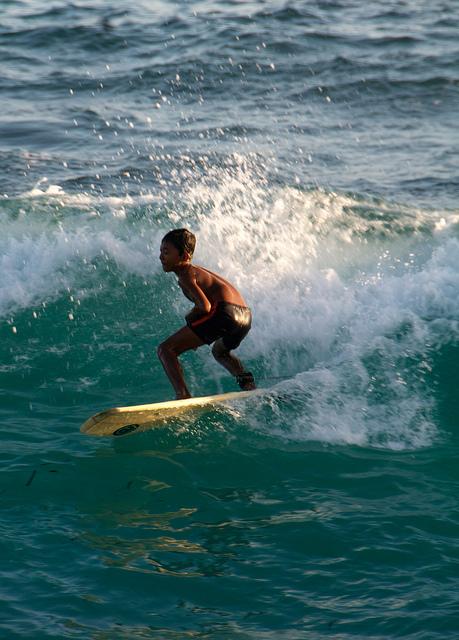Is this person surfing?
Give a very brief answer. Yes. How far down the boys legs do his shorts extend?
Write a very short answer. Mid thigh. What is this  boy on?
Answer briefly. Surfboard. What activity is this boy doing?
Give a very brief answer. Surfing. Is the person wearing jewelry?
Be succinct. No. 